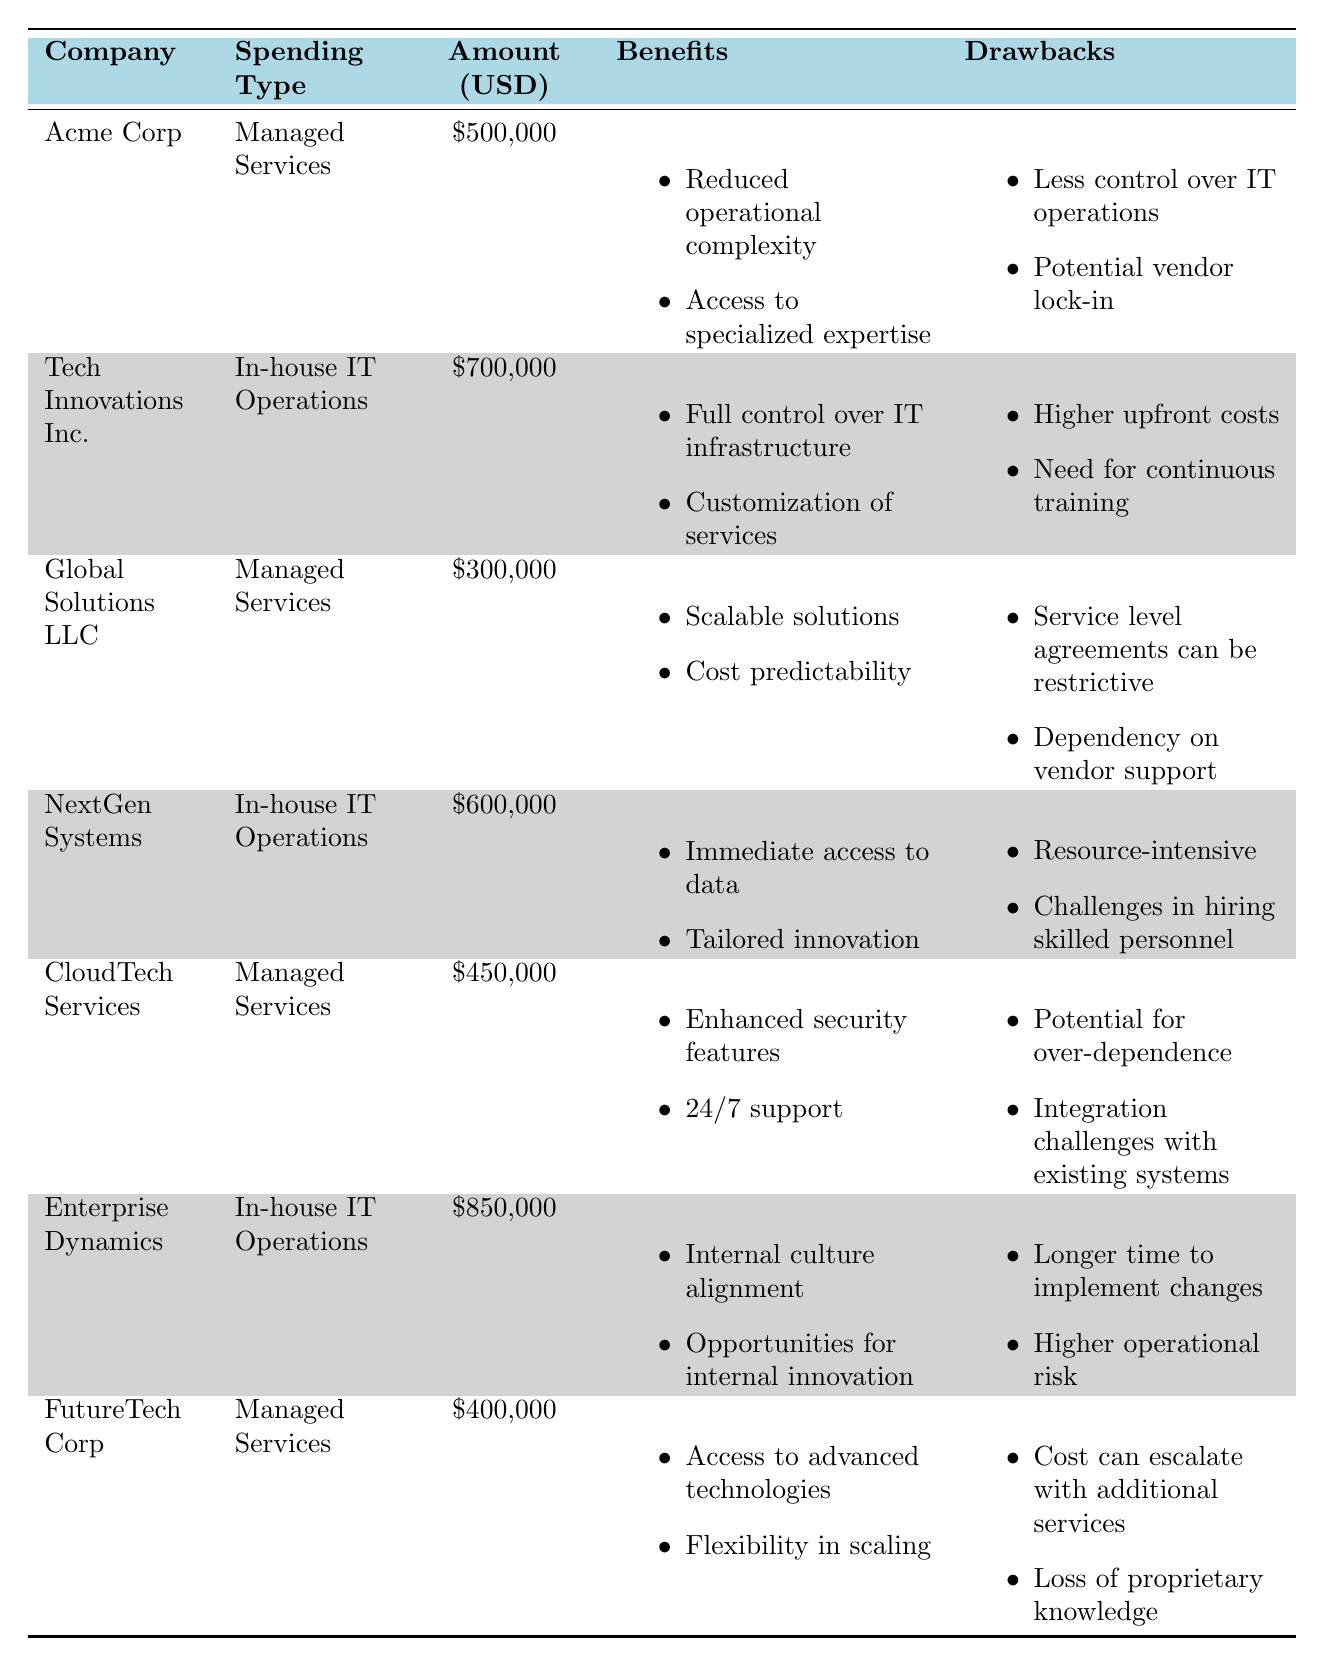What is the total spending on managed services by the companies listed? We can find the total spending on managed services by adding the amounts from the relevant rows. The amounts for managed services are 500,000 (Acme Corp) + 300,000 (Global Solutions LLC) + 450,000 (CloudTech Services) + 400,000 (FutureTech Corp) = 1,650,000.
Answer: 1,650,000 Which company spent the highest on in-house IT operations? Scanning the table for in-house IT operations, we see the amounts: 700,000 (Tech Innovations Inc.), 600,000 (NextGen Systems), and 850,000 (Enterprise Dynamics). The highest spending is 850,000 from Enterprise Dynamics.
Answer: Enterprise Dynamics Is there any company that reported a drawback related to vendor lock-in? Looking through the table, Acme Corp listed vendor lock-in as a drawback for managed services. Thus, the answer is yes.
Answer: Yes What is the average spending on in-house IT operations among the listed companies? The spending amounts for in-house IT operations are 700,000 (Tech Innovations Inc.), 600,000 (NextGen Systems), and 850,000 (Enterprise Dynamics). The total spending is 700,000 + 600,000 + 850,000 = 2,150,000. There are 3 companies, so the average spending is 2,150,000 / 3 = 716,666.67, which we round to 716,667.
Answer: 716,667 Which benefits are unique to managed services when compared to in-house IT operations? Comparing the benefits, we find that managed services include "Reduced operational complexity," "Access to specialized expertise," "Scalable solutions," "Cost predictability," "Enhanced security features," "24/7 support," "Access to advanced technologies," and "Flexibility in scaling." The benefits unique to managed services, not listed under in-house IT operations, are "Reduced operational complexity," "Scalable solutions," "Cost predictability," "Enhanced security features," "24/7 support," and "Flexibility in scaling."
Answer: Reduced operational complexity, Scalable solutions, Cost predictability, Enhanced security features, 24/7 support, Flexibility in scaling Is the drawback "resource-intensive" listed for any company? Checking the table, "resource-intensive" is listed as a drawback for NextGen Systems, which operates in-house IT operations. Therefore, the answer is yes.
Answer: Yes 